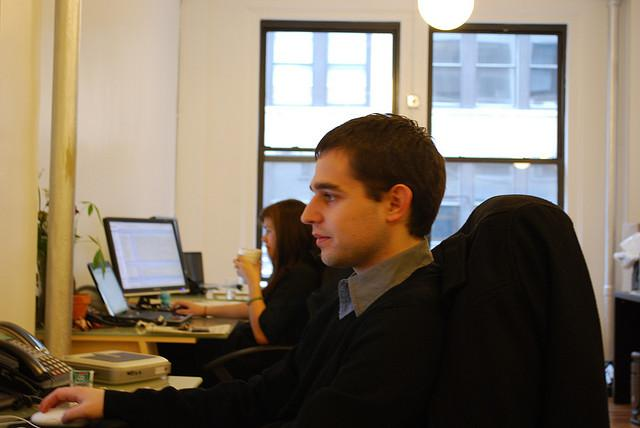What is he doing? Please explain your reasoning. using computer. He has his hand on a mouse and is looking at a screen. 